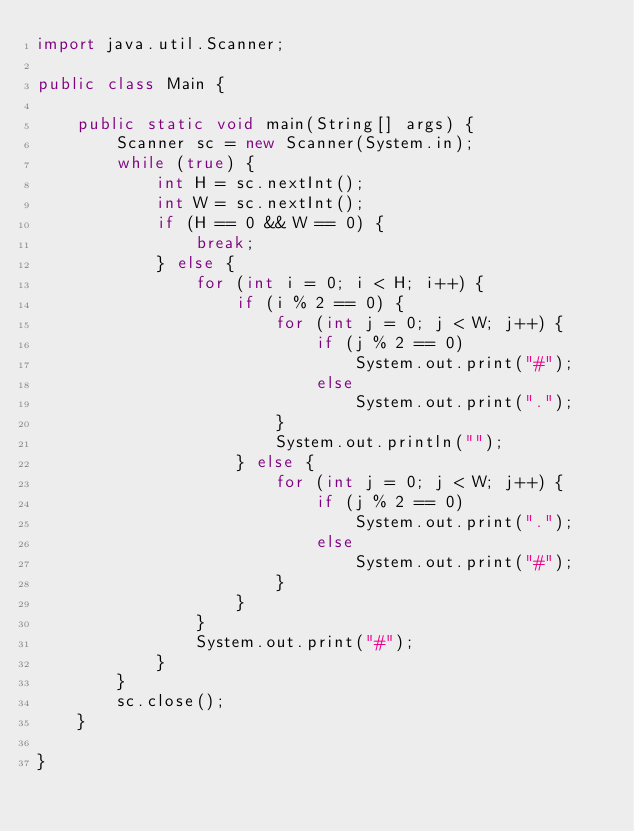<code> <loc_0><loc_0><loc_500><loc_500><_Java_>import java.util.Scanner;

public class Main {

	public static void main(String[] args) {
		Scanner sc = new Scanner(System.in);
		while (true) {
			int H = sc.nextInt();
			int W = sc.nextInt();
			if (H == 0 && W == 0) {
				break;
			} else {
				for (int i = 0; i < H; i++) {
					if (i % 2 == 0) {
						for (int j = 0; j < W; j++) {
							if (j % 2 == 0)
								System.out.print("#");
							else
								System.out.print(".");
						}
						System.out.println("");
					} else {
						for (int j = 0; j < W; j++) {
							if (j % 2 == 0)
								System.out.print(".");
							else
								System.out.print("#");
						}
					}
				}
				System.out.print("#");
			}
		}
		sc.close();
	}

}

</code> 